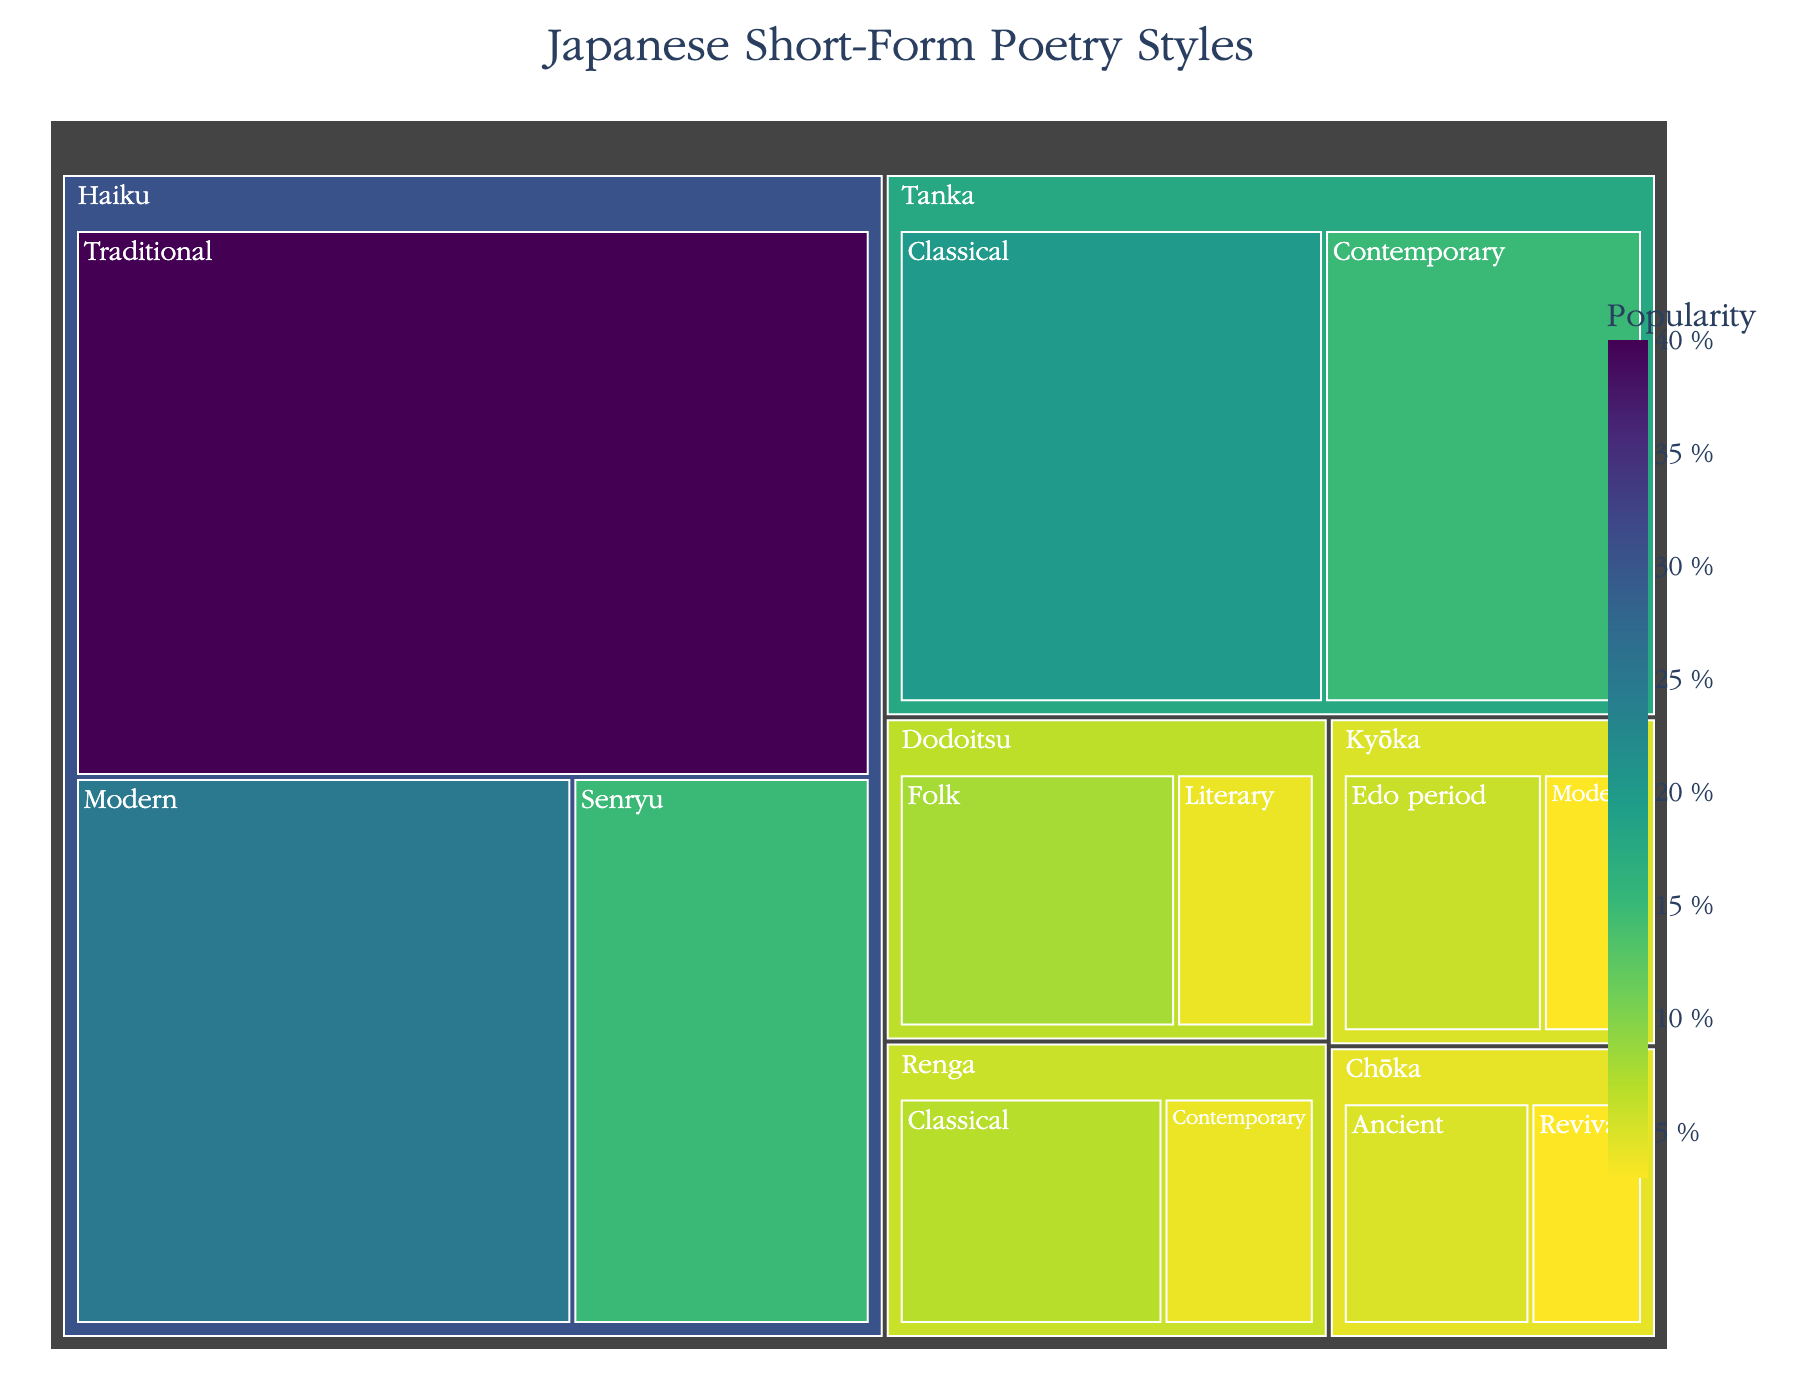What is the total percentage of Haiku styles in the community? To find the total percentage of Haiku styles, sum the values of all Haiku subcategories: Traditional (40), Modern (25), and Senryu (15). So, 40 + 25 + 15 = 80.
Answer: 80% What is the least popular subcategory in the dataset? The least popular subcategory is the one with the smallest value. From the data, the Chōka Revival subcategory has a value of 3, which is the smallest.
Answer: Chōka Revival How does the popularity of Traditional Haiku compare to Contemporary Tanka? The value for Traditional Haiku is 40 and for Contemporary Tanka is 15. Since 40 is greater than 15, Traditional Haiku is more popular.
Answer: Traditional Haiku is more popular Which category has more subcategories, Tanka or Dodoitsu? Count the number of subcategories for each category. Tanka has Classical and Contemporary (2 subcategories), while Dodoitsu has Folk and Literary (2 subcategories). Since both have 2 subcategories, they are equal.
Answer: They are equal What is the combined percentage of all subcategories in the Tanka category? Sum the values of Classical (20) and Contemporary (15) subcategories of Tanka. So, 20 + 15 = 35.
Answer: 35% Is Modern Kyōka more popular than Literary Dodoitsu? The Modern Kyōka has a value of 3 and Literary Dodoitsu has a value of 4. Since 3 is less than 4, Modern Kyōka is less popular.
Answer: No, it is less popular What is the average value of Classical subcategories across all categories? Identify all Classical subcategories: Tanka (20), Renga (7). Sum these values, 20 + 7 = 27, and divide by the number of Classical subcategories (2). So, 27 / 2 = 13.5.
Answer: 13.5 Which category has the highest total value: Haiku, Tanka, or Chōka? Sum the subcategory values for each category. Haiku (Traditional 40 + Modern 25 + Senryu 15 = 80), Tanka (Classical 20 + Contemporary 15 = 35), Chōka (Ancient 5 + Revival 3 = 8). Haiku has the highest total value of 80.
Answer: Haiku What percentage of the total does the Folk Dodoitsu subcategory represent? Calculate the total value of all subcategories, which is 40 + 25 + 15 + 20 + 15 + 5 + 3 + 8 + 4 + 6 + 3 + 7 + 4 = 155. The value of Folk Dodoitsu is 8. So, (8 / 155) * 100 ≈ 5.16%.
Answer: Approx. 5.16% 